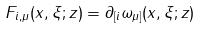Convert formula to latex. <formula><loc_0><loc_0><loc_500><loc_500>F _ { i , \mu } ( x , \xi ; z ) = \partial _ { [ i } \omega _ { \mu ] } ( x , \xi ; z )</formula> 